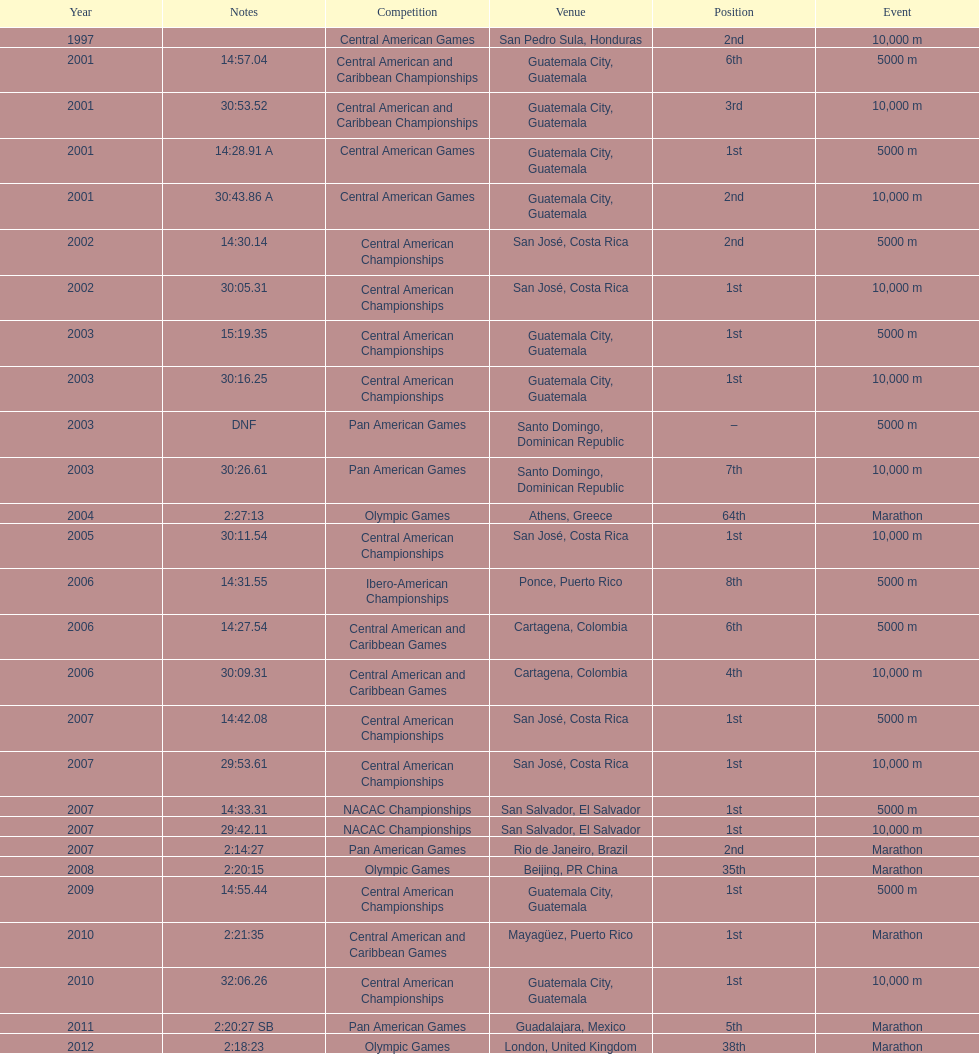What was the last competition in which a position of "2nd" was achieved? Pan American Games. 